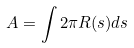<formula> <loc_0><loc_0><loc_500><loc_500>A = \int 2 \pi R ( s ) d s</formula> 